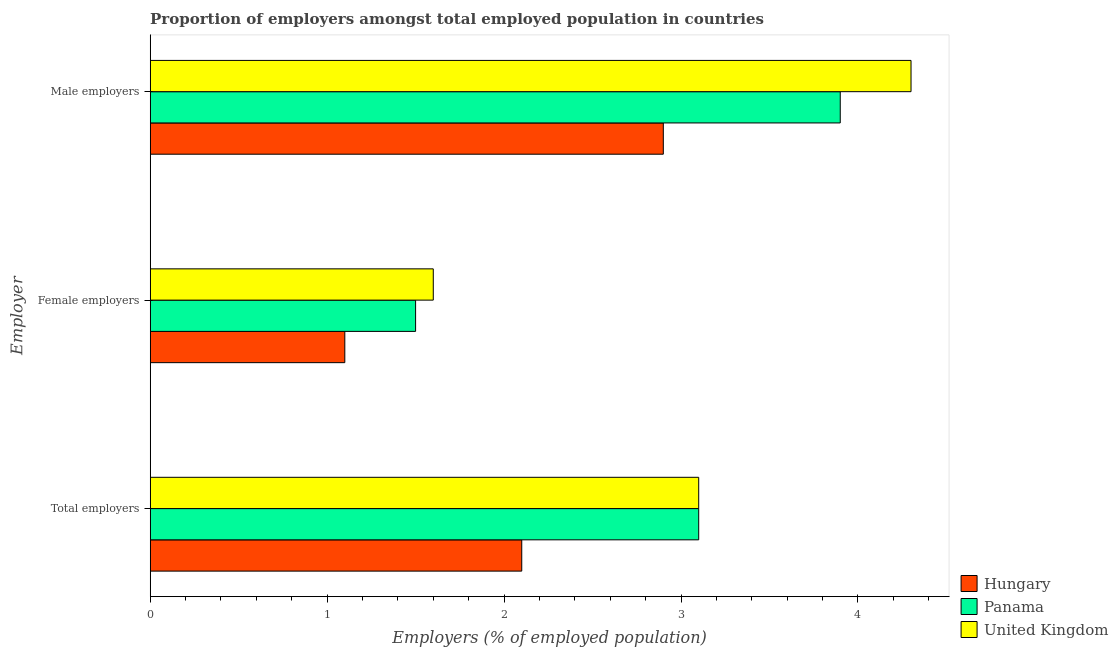How many groups of bars are there?
Provide a succinct answer. 3. What is the label of the 3rd group of bars from the top?
Provide a short and direct response. Total employers. What is the percentage of total employers in Hungary?
Offer a terse response. 2.1. Across all countries, what is the maximum percentage of male employers?
Keep it short and to the point. 4.3. Across all countries, what is the minimum percentage of total employers?
Give a very brief answer. 2.1. In which country was the percentage of total employers maximum?
Ensure brevity in your answer.  Panama. In which country was the percentage of female employers minimum?
Provide a short and direct response. Hungary. What is the total percentage of female employers in the graph?
Make the answer very short. 4.2. What is the difference between the percentage of male employers in United Kingdom and that in Panama?
Provide a short and direct response. 0.4. What is the difference between the percentage of male employers in Hungary and the percentage of total employers in United Kingdom?
Offer a terse response. -0.2. What is the average percentage of male employers per country?
Offer a terse response. 3.7. What is the difference between the percentage of female employers and percentage of total employers in Hungary?
Make the answer very short. -1. What is the ratio of the percentage of female employers in Hungary to that in Panama?
Offer a terse response. 0.73. Is the percentage of total employers in Panama less than that in Hungary?
Ensure brevity in your answer.  No. What is the difference between the highest and the second highest percentage of male employers?
Make the answer very short. 0.4. What is the difference between the highest and the lowest percentage of female employers?
Keep it short and to the point. 0.5. What does the 3rd bar from the top in Male employers represents?
Provide a short and direct response. Hungary. What does the 1st bar from the bottom in Male employers represents?
Your answer should be compact. Hungary. How many bars are there?
Your answer should be very brief. 9. Are all the bars in the graph horizontal?
Offer a terse response. Yes. Are the values on the major ticks of X-axis written in scientific E-notation?
Provide a short and direct response. No. Where does the legend appear in the graph?
Your answer should be compact. Bottom right. How many legend labels are there?
Offer a terse response. 3. How are the legend labels stacked?
Provide a succinct answer. Vertical. What is the title of the graph?
Ensure brevity in your answer.  Proportion of employers amongst total employed population in countries. Does "Seychelles" appear as one of the legend labels in the graph?
Offer a terse response. No. What is the label or title of the X-axis?
Your response must be concise. Employers (% of employed population). What is the label or title of the Y-axis?
Your answer should be very brief. Employer. What is the Employers (% of employed population) of Hungary in Total employers?
Offer a terse response. 2.1. What is the Employers (% of employed population) in Panama in Total employers?
Make the answer very short. 3.1. What is the Employers (% of employed population) of United Kingdom in Total employers?
Provide a succinct answer. 3.1. What is the Employers (% of employed population) of Hungary in Female employers?
Offer a terse response. 1.1. What is the Employers (% of employed population) of United Kingdom in Female employers?
Offer a terse response. 1.6. What is the Employers (% of employed population) in Hungary in Male employers?
Your response must be concise. 2.9. What is the Employers (% of employed population) in Panama in Male employers?
Your answer should be compact. 3.9. What is the Employers (% of employed population) of United Kingdom in Male employers?
Your answer should be compact. 4.3. Across all Employer, what is the maximum Employers (% of employed population) in Hungary?
Make the answer very short. 2.9. Across all Employer, what is the maximum Employers (% of employed population) of Panama?
Keep it short and to the point. 3.9. Across all Employer, what is the maximum Employers (% of employed population) in United Kingdom?
Offer a terse response. 4.3. Across all Employer, what is the minimum Employers (% of employed population) of Hungary?
Make the answer very short. 1.1. Across all Employer, what is the minimum Employers (% of employed population) of United Kingdom?
Give a very brief answer. 1.6. What is the total Employers (% of employed population) of United Kingdom in the graph?
Give a very brief answer. 9. What is the difference between the Employers (% of employed population) in Hungary in Total employers and that in Female employers?
Your response must be concise. 1. What is the difference between the Employers (% of employed population) in Panama in Total employers and that in Female employers?
Your response must be concise. 1.6. What is the difference between the Employers (% of employed population) of Hungary in Total employers and that in Male employers?
Keep it short and to the point. -0.8. What is the difference between the Employers (% of employed population) of Panama in Total employers and that in Male employers?
Provide a short and direct response. -0.8. What is the difference between the Employers (% of employed population) in United Kingdom in Total employers and that in Male employers?
Give a very brief answer. -1.2. What is the difference between the Employers (% of employed population) in Hungary in Total employers and the Employers (% of employed population) in Panama in Female employers?
Offer a terse response. 0.6. What is the difference between the Employers (% of employed population) of Panama in Total employers and the Employers (% of employed population) of United Kingdom in Female employers?
Offer a terse response. 1.5. What is the difference between the Employers (% of employed population) in Hungary in Total employers and the Employers (% of employed population) in Panama in Male employers?
Give a very brief answer. -1.8. What is the difference between the Employers (% of employed population) of Panama in Total employers and the Employers (% of employed population) of United Kingdom in Male employers?
Your response must be concise. -1.2. What is the difference between the Employers (% of employed population) in Hungary in Female employers and the Employers (% of employed population) in Panama in Male employers?
Your response must be concise. -2.8. What is the difference between the Employers (% of employed population) in Hungary in Female employers and the Employers (% of employed population) in United Kingdom in Male employers?
Offer a very short reply. -3.2. What is the difference between the Employers (% of employed population) of Panama in Female employers and the Employers (% of employed population) of United Kingdom in Male employers?
Provide a succinct answer. -2.8. What is the average Employers (% of employed population) of Hungary per Employer?
Keep it short and to the point. 2.03. What is the average Employers (% of employed population) of Panama per Employer?
Provide a short and direct response. 2.83. What is the average Employers (% of employed population) in United Kingdom per Employer?
Make the answer very short. 3. What is the difference between the Employers (% of employed population) of Hungary and Employers (% of employed population) of Panama in Total employers?
Keep it short and to the point. -1. What is the difference between the Employers (% of employed population) in Hungary and Employers (% of employed population) in United Kingdom in Total employers?
Make the answer very short. -1. What is the difference between the Employers (% of employed population) of Panama and Employers (% of employed population) of United Kingdom in Total employers?
Provide a short and direct response. 0. What is the difference between the Employers (% of employed population) of Hungary and Employers (% of employed population) of Panama in Female employers?
Give a very brief answer. -0.4. What is the difference between the Employers (% of employed population) of Hungary and Employers (% of employed population) of United Kingdom in Female employers?
Your answer should be compact. -0.5. What is the difference between the Employers (% of employed population) in Panama and Employers (% of employed population) in United Kingdom in Male employers?
Give a very brief answer. -0.4. What is the ratio of the Employers (% of employed population) of Hungary in Total employers to that in Female employers?
Your answer should be compact. 1.91. What is the ratio of the Employers (% of employed population) of Panama in Total employers to that in Female employers?
Your response must be concise. 2.07. What is the ratio of the Employers (% of employed population) in United Kingdom in Total employers to that in Female employers?
Provide a short and direct response. 1.94. What is the ratio of the Employers (% of employed population) in Hungary in Total employers to that in Male employers?
Provide a succinct answer. 0.72. What is the ratio of the Employers (% of employed population) in Panama in Total employers to that in Male employers?
Your answer should be very brief. 0.79. What is the ratio of the Employers (% of employed population) in United Kingdom in Total employers to that in Male employers?
Your response must be concise. 0.72. What is the ratio of the Employers (% of employed population) in Hungary in Female employers to that in Male employers?
Ensure brevity in your answer.  0.38. What is the ratio of the Employers (% of employed population) in Panama in Female employers to that in Male employers?
Your answer should be compact. 0.38. What is the ratio of the Employers (% of employed population) of United Kingdom in Female employers to that in Male employers?
Your answer should be very brief. 0.37. What is the difference between the highest and the second highest Employers (% of employed population) in Hungary?
Keep it short and to the point. 0.8. What is the difference between the highest and the second highest Employers (% of employed population) of Panama?
Your answer should be very brief. 0.8. What is the difference between the highest and the second highest Employers (% of employed population) of United Kingdom?
Ensure brevity in your answer.  1.2. 